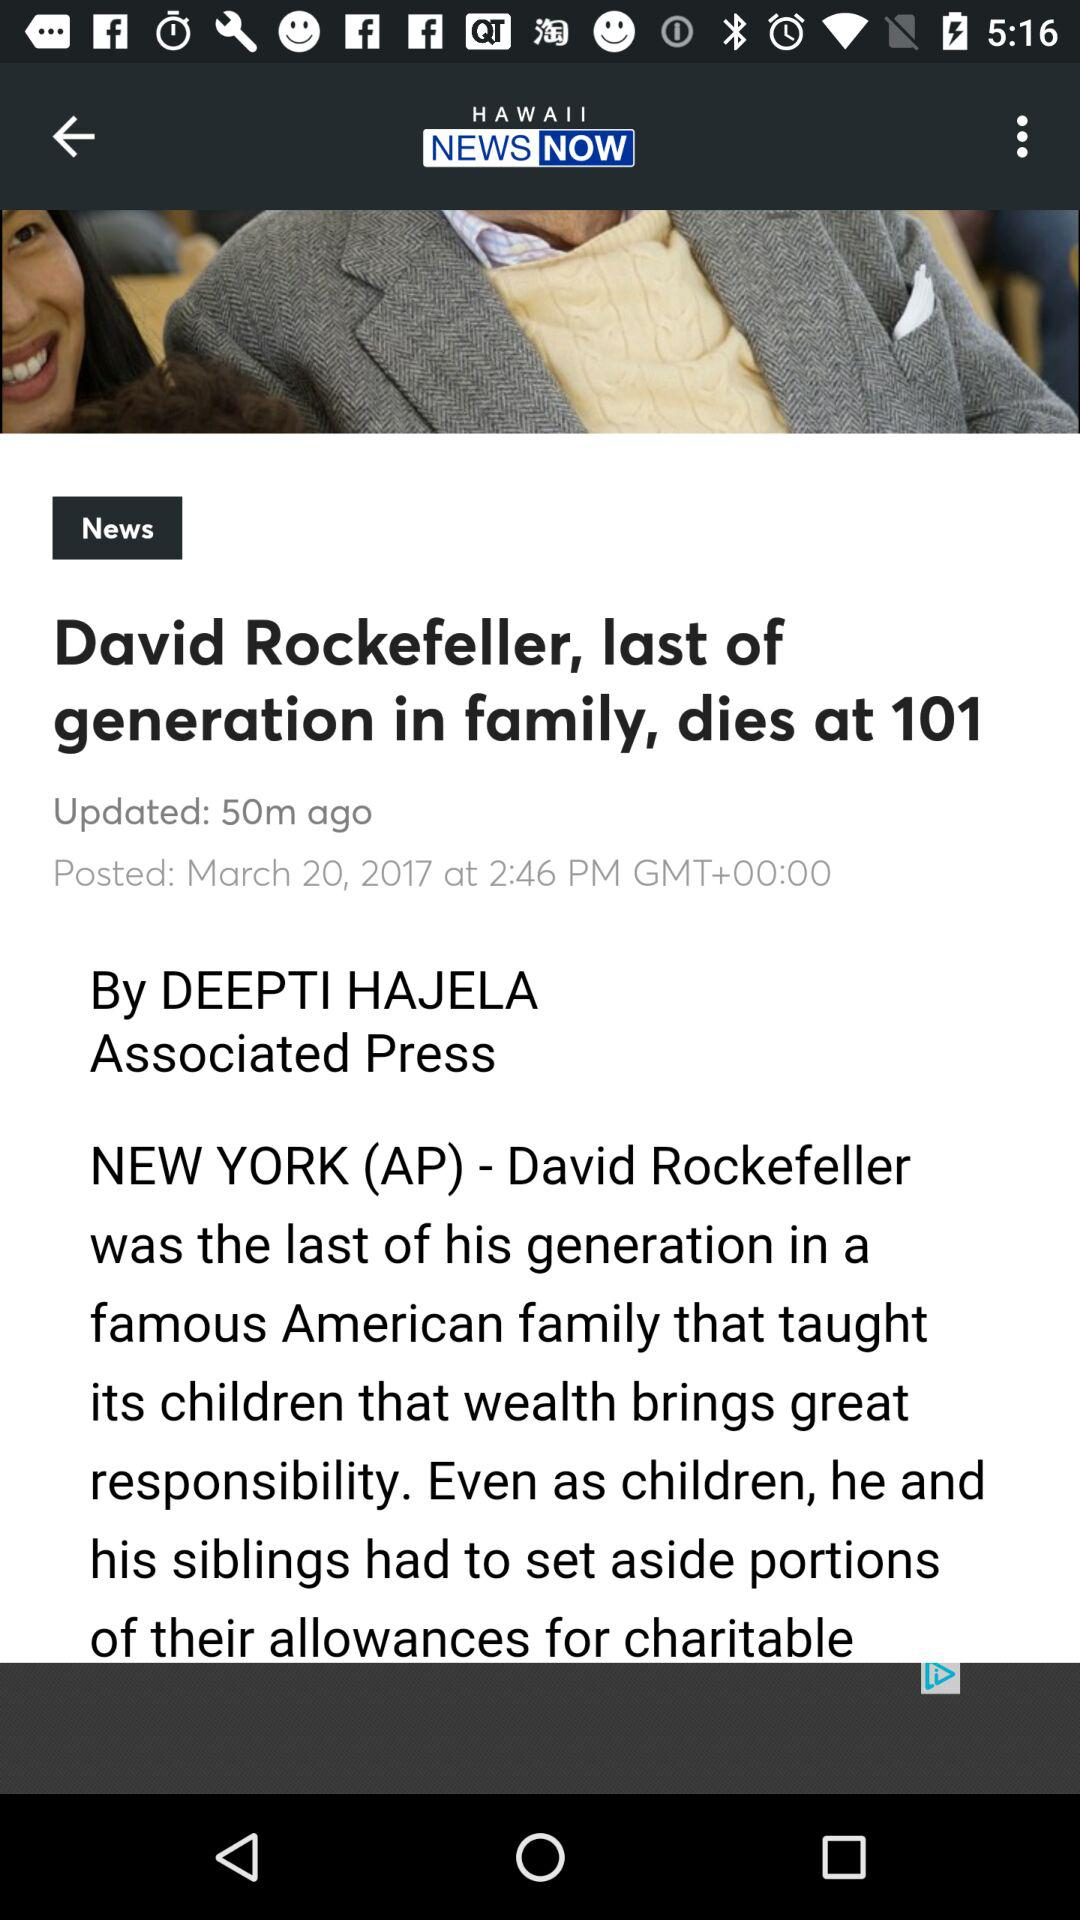What is the posted date of the article? The posted date is March 20, 2017. 